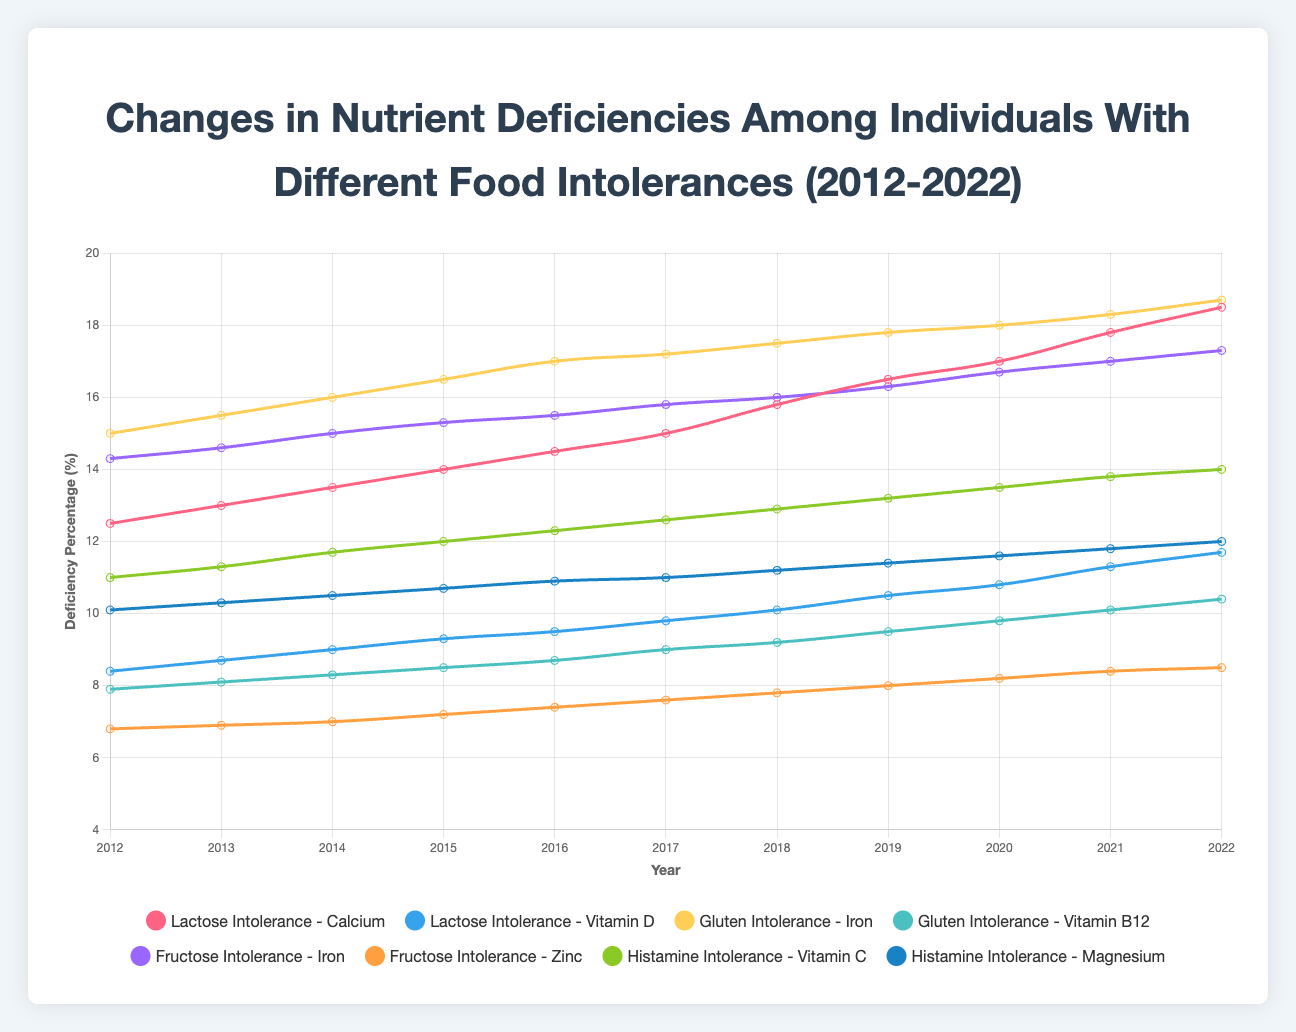What was the calcium deficiency percentage for lactose intolerance in 2020? Check the plotted line for "Lactose Intolerance - Calcium" in 2020; it shows a value of 17.0%
Answer: 17.0% Which nutrient deficiency saw a greater increase over the decade: Iron with gluten intolerance or Iron with fructose intolerance? Compare the increase from 2012 to 2022 for Iron in both intolerances. For gluten intolerance, it increased from 15.0% to 18.7% (an increase of 3.7%). For fructose intolerance, it increased from 14.3% to 17.3% (an increase of 3.0%)
Answer: Iron with gluten intolerance Among the deficiencies tracked for lactose intolerance, which nutrient showed a higher deficiency percentage in 2022? Compare the end points at 2022 for both "Lactose Intolerance - Calcium" and "Lactose Intolerance - Vitamin D". Calcium is at 18.5% and Vitamin D is at 11.7%
Answer: Calcium In what year did the vitamin C deficiency for histamine intolerance reach 12.0%? Check where the plotted line for "Histamine Intolerance - Vitamin C" intersects the 12.0% mark; this occurs in 2015
Answer: 2015 What is the average deficiency percentage for zinc with fructose intolerance over the decade? Sum the data points for Zinc in fructose intolerance and divide by the number of years: (6.8 + 6.9 + 7.0 + 7.2 + 7.4 + 7.6 + 7.8 + 8.0 + 8.2 + 8.4 + 8.5) / 11 = 8.0%
Answer: 8.0% By how much did the magnesium deficiency for histamine intolerance change from 2012 to 2022? Subtract the 2012 value from the 2022 value for "Histamine Intolerance - Magnesium": 12.0% - 10.1% = 1.9%
Answer: 1.9% Which nutrient with a food intolerance showed the lowest deficiency percentage in 2014? Compare the values in 2014 for all nutrient deficiencies: Lactose Intolerance - Calcium (13.5%), Lactose Intolerance - Vitamin D (9.0%), Gluten Intolerance - Iron (16.0%), Gluten Intolerance - Vitamin B12 (8.3%), Fructose Intolerance - Iron (15.0%), Fructose Intolerance - Zinc (7.0%), Histamine Intolerance - Vitamin C (11.7%), Histamine Intolerance - Magnesium (10.5%). The lowest is for Fructose Intolerance - Zinc at 7.0%
Answer: Zinc with fructose intolerance Between 2012 and 2016, which nutrient for gluten intolerance showed the smallest increase in deficiency percentage? Calculate the increase for each nutrient in gluten intolerance over those years. Iron went from 15.0% to 17.0% (an increase of 2%), while Vitamin B12 went from 7.9% to 8.7% (an increase of 0.8%). The smallest increase is for Vitamin B12
Answer: Vitamin B12 What is the difference in calcium deficiency percentage for lactose intolerance between 2015 and 2019? Subtract the 2015 value from the 2019 value for "Lactose Intolerance - Calcium": 16.5% - 14.0% = 2.5%
Answer: 2.5% Does the helium intolerance condition exhibit any of the tracked nutrient deficiencies? Helium intolerance is not listed among the tracked food intolerances in the dataset
Answer: No 